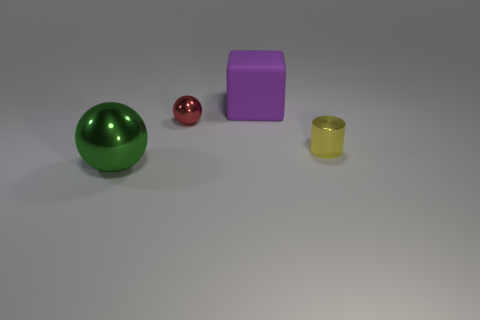Subtract all cylinders. How many objects are left? 3 Add 2 blocks. How many objects exist? 6 Subtract all big purple matte objects. Subtract all tiny shiny balls. How many objects are left? 2 Add 4 small yellow shiny cylinders. How many small yellow shiny cylinders are left? 5 Add 4 red rubber cubes. How many red rubber cubes exist? 4 Subtract 0 blue spheres. How many objects are left? 4 